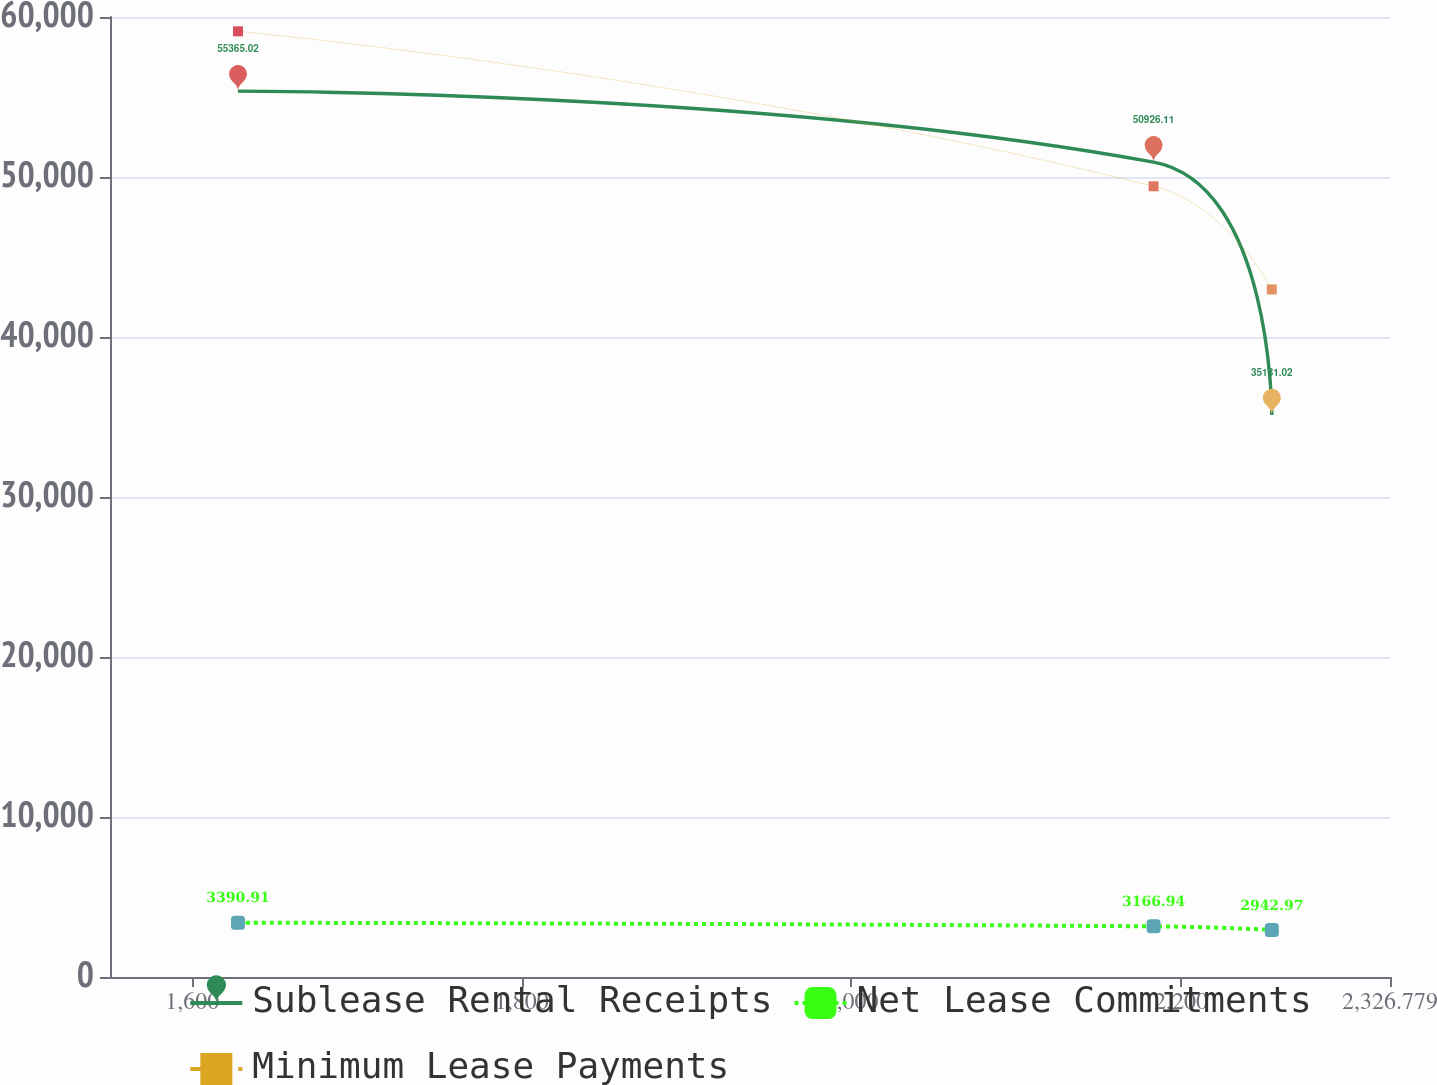Convert chart. <chart><loc_0><loc_0><loc_500><loc_500><line_chart><ecel><fcel>Sublease Rental Receipts<fcel>Net Lease Commitments<fcel>Minimum Lease Payments<nl><fcel>1627.83<fcel>55365<fcel>3390.91<fcel>59105.6<nl><fcel>2183.33<fcel>50926.1<fcel>3166.94<fcel>49420.6<nl><fcel>2255.07<fcel>35131<fcel>2942.97<fcel>42972.2<nl><fcel>2332.7<fcel>27215<fcel>2051.7<fcel>31955.5<nl><fcel>2404.44<fcel>22782.8<fcel>897.07<fcel>18837.7<nl></chart> 